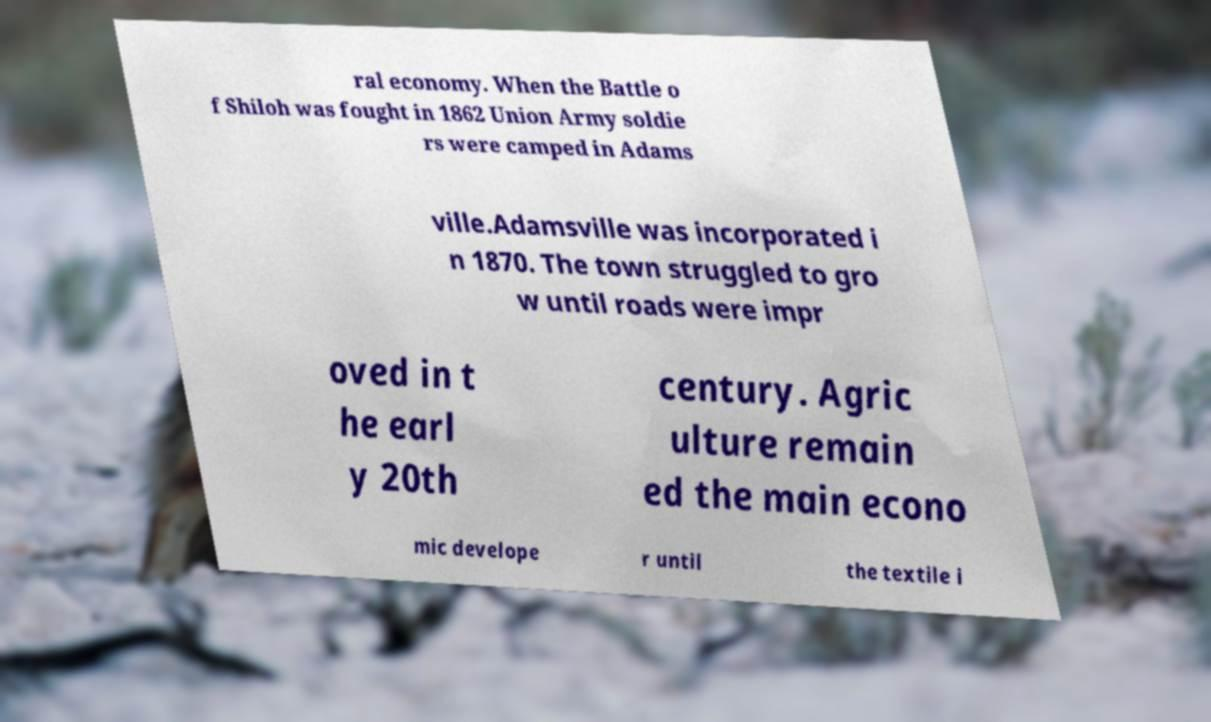Please read and relay the text visible in this image. What does it say? ral economy. When the Battle o f Shiloh was fought in 1862 Union Army soldie rs were camped in Adams ville.Adamsville was incorporated i n 1870. The town struggled to gro w until roads were impr oved in t he earl y 20th century. Agric ulture remain ed the main econo mic develope r until the textile i 